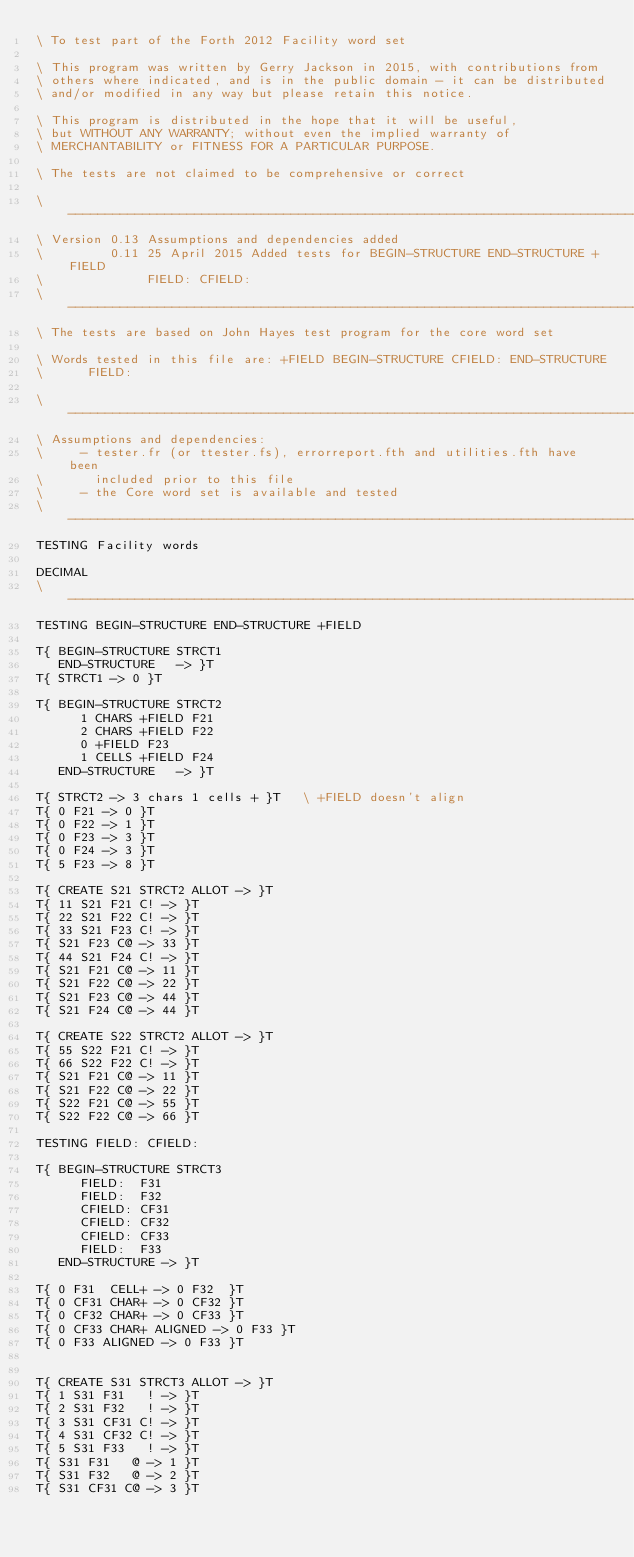<code> <loc_0><loc_0><loc_500><loc_500><_Forth_>\ To test part of the Forth 2012 Facility word set

\ This program was written by Gerry Jackson in 2015, with contributions from
\ others where indicated, and is in the public domain - it can be distributed
\ and/or modified in any way but please retain this notice.

\ This program is distributed in the hope that it will be useful,
\ but WITHOUT ANY WARRANTY; without even the implied warranty of
\ MERCHANTABILITY or FITNESS FOR A PARTICULAR PURPOSE.

\ The tests are not claimed to be comprehensive or correct 

\ ------------------------------------------------------------------------------
\ Version 0.13 Assumptions and dependencies added
\         0.11 25 April 2015 Added tests for BEGIN-STRUCTURE END-STRUCTURE +FIELD
\              FIELD: CFIELD:
\ -----------------------------------------------------------------------------
\ The tests are based on John Hayes test program for the core word set

\ Words tested in this file are: +FIELD BEGIN-STRUCTURE CFIELD: END-STRUCTURE
\      FIELD:

\ ------------------------------------------------------------------------------
\ Assumptions and dependencies:
\     - tester.fr (or ttester.fs), errorreport.fth and utilities.fth have been
\       included prior to this file
\     - the Core word set is available and tested
\ -----------------------------------------------------------------------------
TESTING Facility words

DECIMAL
\ -----------------------------------------------------------------------------
TESTING BEGIN-STRUCTURE END-STRUCTURE +FIELD

T{ BEGIN-STRUCTURE STRCT1
   END-STRUCTURE   -> }T
T{ STRCT1 -> 0 }T

T{ BEGIN-STRUCTURE STRCT2
      1 CHARS +FIELD F21
      2 CHARS +FIELD F22
      0 +FIELD F23
      1 CELLS +FIELD F24
   END-STRUCTURE   -> }T

T{ STRCT2 -> 3 chars 1 cells + }T   \ +FIELD doesn't align
T{ 0 F21 -> 0 }T
T{ 0 F22 -> 1 }T
T{ 0 F23 -> 3 }T
T{ 0 F24 -> 3 }T
T{ 5 F23 -> 8 }T

T{ CREATE S21 STRCT2 ALLOT -> }T
T{ 11 S21 F21 C! -> }T
T{ 22 S21 F22 C! -> }T
T{ 33 S21 F23 C! -> }T
T{ S21 F23 C@ -> 33 }T
T{ 44 S21 F24 C! -> }T
T{ S21 F21 C@ -> 11 }T
T{ S21 F22 C@ -> 22 }T
T{ S21 F23 C@ -> 44 }T
T{ S21 F24 C@ -> 44 }T

T{ CREATE S22 STRCT2 ALLOT -> }T
T{ 55 S22 F21 C! -> }T
T{ 66 S22 F22 C! -> }T
T{ S21 F21 C@ -> 11 }T
T{ S21 F22 C@ -> 22 }T
T{ S22 F21 C@ -> 55 }T
T{ S22 F22 C@ -> 66 }T

TESTING FIELD: CFIELD:

T{ BEGIN-STRUCTURE STRCT3
      FIELD:  F31
      FIELD:  F32
      CFIELD: CF31
      CFIELD: CF32
      CFIELD: CF33
      FIELD:  F33
   END-STRUCTURE -> }T

T{ 0 F31  CELL+ -> 0 F32  }T
T{ 0 CF31 CHAR+ -> 0 CF32 }T
T{ 0 CF32 CHAR+ -> 0 CF33 }T
T{ 0 CF33 CHAR+ ALIGNED -> 0 F33 }T
T{ 0 F33 ALIGNED -> 0 F33 }T


T{ CREATE S31 STRCT3 ALLOT -> }T
T{ 1 S31 F31   ! -> }T
T{ 2 S31 F32   ! -> }T
T{ 3 S31 CF31 C! -> }T
T{ 4 S31 CF32 C! -> }T
T{ 5 S31 F33   ! -> }T
T{ S31 F31   @ -> 1 }T
T{ S31 F32   @ -> 2 }T
T{ S31 CF31 C@ -> 3 }T</code> 